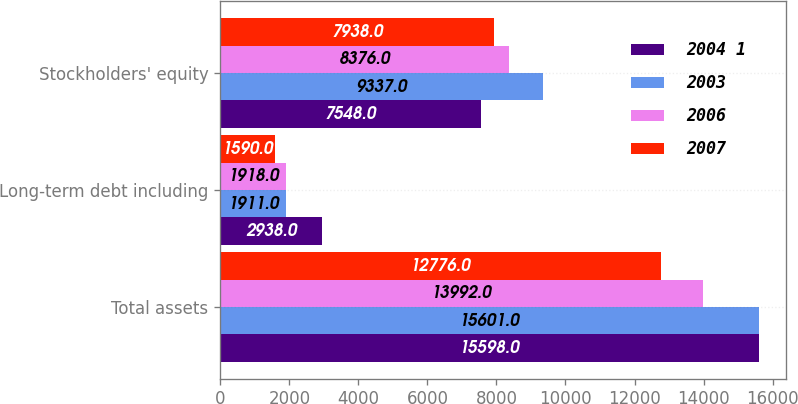<chart> <loc_0><loc_0><loc_500><loc_500><stacked_bar_chart><ecel><fcel>Total assets<fcel>Long-term debt including<fcel>Stockholders' equity<nl><fcel>2004 1<fcel>15598<fcel>2938<fcel>7548<nl><fcel>2003<fcel>15601<fcel>1911<fcel>9337<nl><fcel>2006<fcel>13992<fcel>1918<fcel>8376<nl><fcel>2007<fcel>12776<fcel>1590<fcel>7938<nl></chart> 